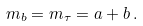Convert formula to latex. <formula><loc_0><loc_0><loc_500><loc_500>m _ { b } = m _ { \tau } = a + b \, .</formula> 